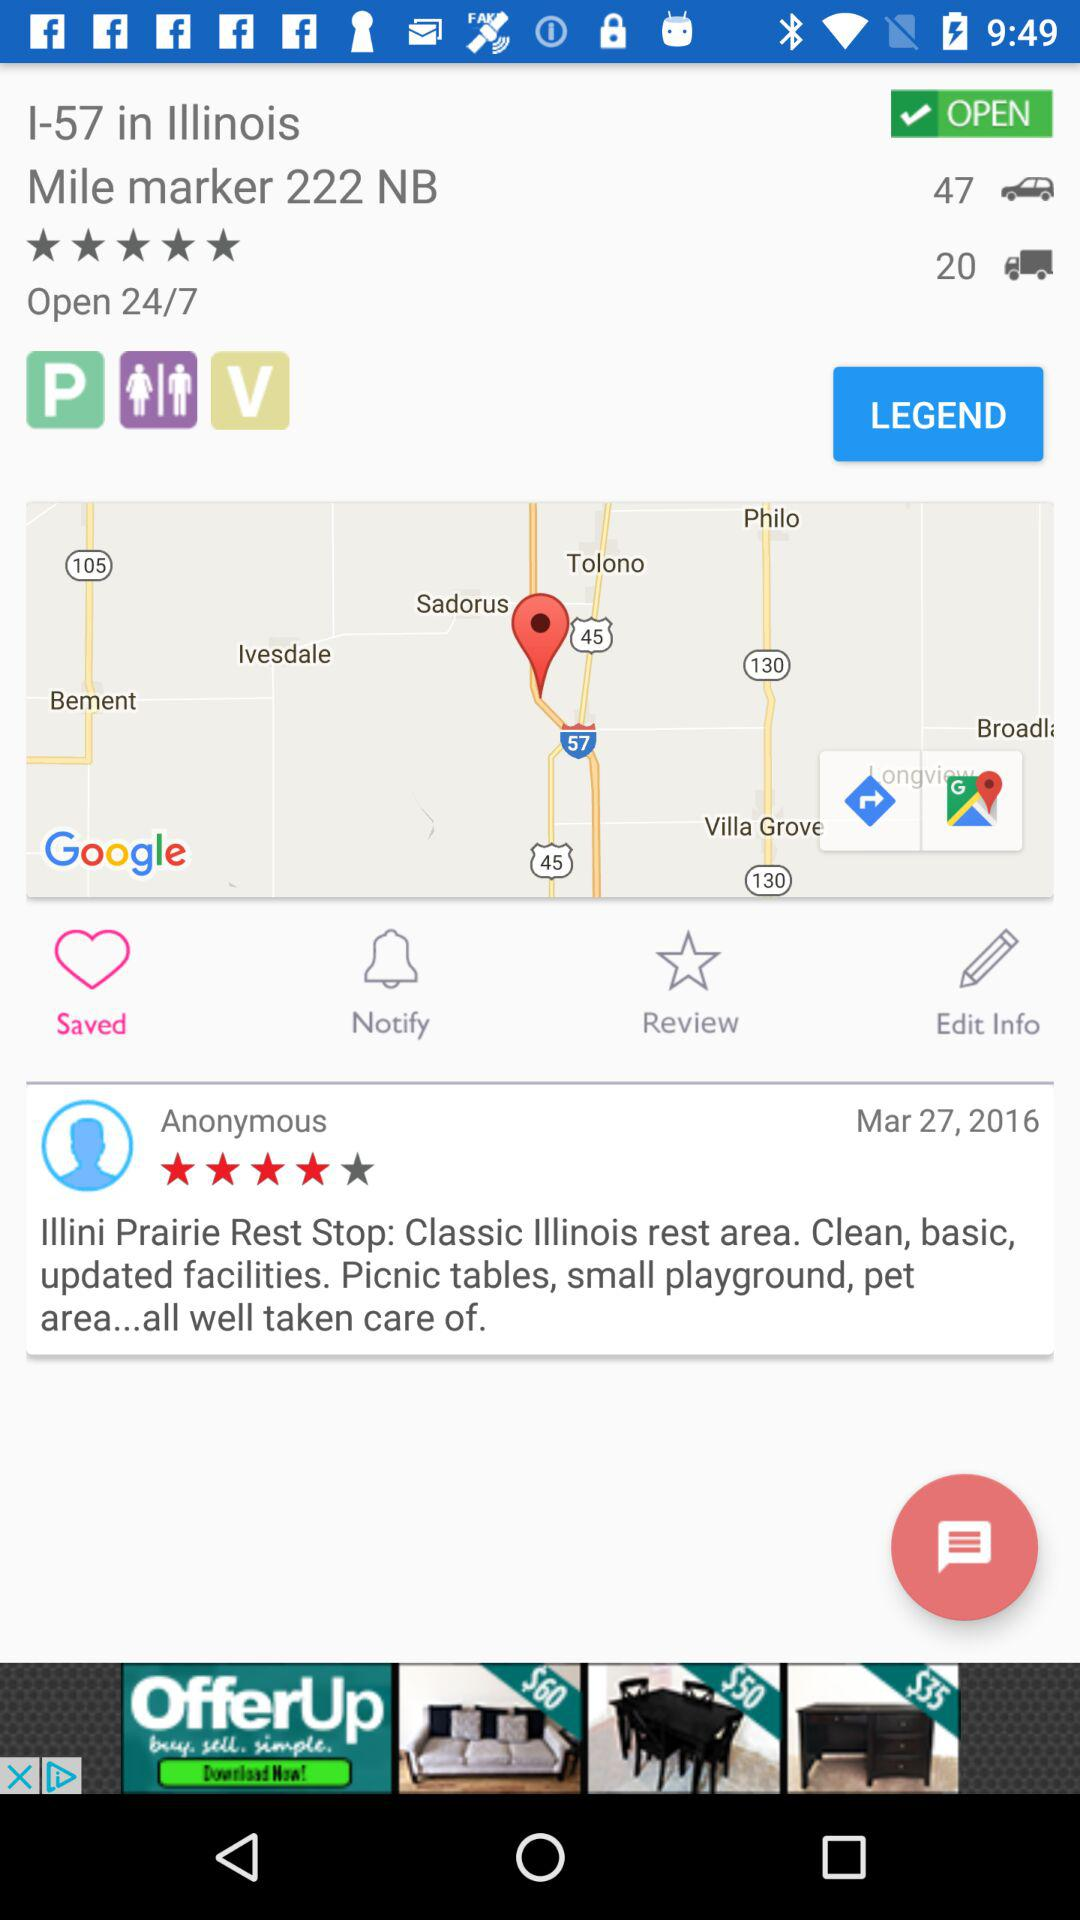What is the total count of cars? The total count of cars is 47. 